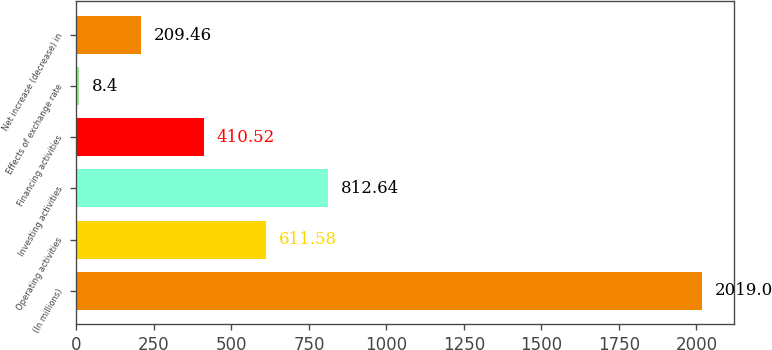Convert chart. <chart><loc_0><loc_0><loc_500><loc_500><bar_chart><fcel>(In millions)<fcel>Operating activities<fcel>Investing activities<fcel>Financing activities<fcel>Effects of exchange rate<fcel>Net increase (decrease) in<nl><fcel>2019<fcel>611.58<fcel>812.64<fcel>410.52<fcel>8.4<fcel>209.46<nl></chart> 